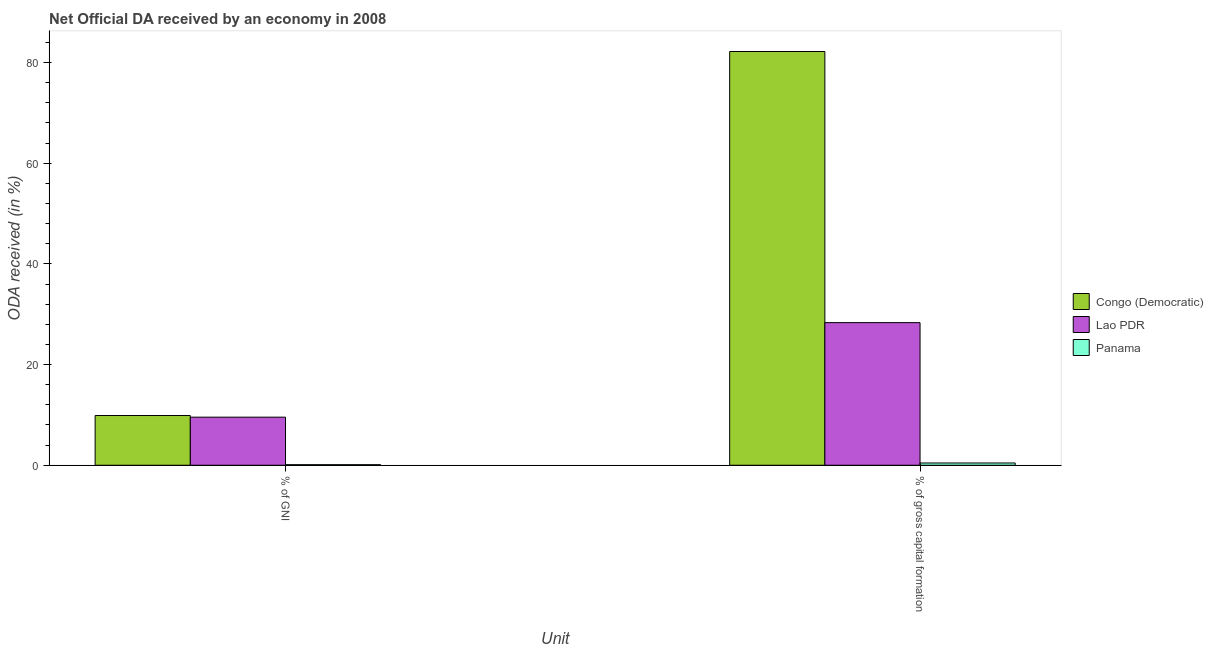How many different coloured bars are there?
Keep it short and to the point. 3. How many groups of bars are there?
Provide a short and direct response. 2. Are the number of bars on each tick of the X-axis equal?
Offer a very short reply. Yes. How many bars are there on the 2nd tick from the left?
Provide a succinct answer. 3. What is the label of the 2nd group of bars from the left?
Give a very brief answer. % of gross capital formation. What is the oda received as percentage of gni in Lao PDR?
Offer a terse response. 9.55. Across all countries, what is the maximum oda received as percentage of gni?
Your answer should be compact. 9.88. Across all countries, what is the minimum oda received as percentage of gross capital formation?
Offer a very short reply. 0.45. In which country was the oda received as percentage of gni maximum?
Offer a very short reply. Congo (Democratic). In which country was the oda received as percentage of gross capital formation minimum?
Provide a succinct answer. Panama. What is the total oda received as percentage of gross capital formation in the graph?
Your answer should be compact. 110.98. What is the difference between the oda received as percentage of gross capital formation in Congo (Democratic) and that in Panama?
Your answer should be very brief. 81.75. What is the difference between the oda received as percentage of gross capital formation in Congo (Democratic) and the oda received as percentage of gni in Panama?
Provide a short and direct response. 82.09. What is the average oda received as percentage of gross capital formation per country?
Give a very brief answer. 36.99. What is the difference between the oda received as percentage of gni and oda received as percentage of gross capital formation in Panama?
Offer a terse response. -0.34. In how many countries, is the oda received as percentage of gni greater than 68 %?
Make the answer very short. 0. What is the ratio of the oda received as percentage of gross capital formation in Lao PDR to that in Congo (Democratic)?
Offer a very short reply. 0.34. Is the oda received as percentage of gni in Congo (Democratic) less than that in Lao PDR?
Your answer should be compact. No. What does the 1st bar from the left in % of gross capital formation represents?
Your answer should be very brief. Congo (Democratic). What does the 3rd bar from the right in % of gross capital formation represents?
Provide a short and direct response. Congo (Democratic). How many countries are there in the graph?
Offer a very short reply. 3. Are the values on the major ticks of Y-axis written in scientific E-notation?
Make the answer very short. No. How are the legend labels stacked?
Provide a short and direct response. Vertical. What is the title of the graph?
Offer a terse response. Net Official DA received by an economy in 2008. Does "Tuvalu" appear as one of the legend labels in the graph?
Keep it short and to the point. No. What is the label or title of the X-axis?
Make the answer very short. Unit. What is the label or title of the Y-axis?
Offer a very short reply. ODA received (in %). What is the ODA received (in %) of Congo (Democratic) in % of GNI?
Give a very brief answer. 9.88. What is the ODA received (in %) of Lao PDR in % of GNI?
Offer a terse response. 9.55. What is the ODA received (in %) in Panama in % of GNI?
Provide a succinct answer. 0.11. What is the ODA received (in %) in Congo (Democratic) in % of gross capital formation?
Provide a succinct answer. 82.2. What is the ODA received (in %) in Lao PDR in % of gross capital formation?
Offer a very short reply. 28.33. What is the ODA received (in %) in Panama in % of gross capital formation?
Provide a succinct answer. 0.45. Across all Unit, what is the maximum ODA received (in %) of Congo (Democratic)?
Your response must be concise. 82.2. Across all Unit, what is the maximum ODA received (in %) in Lao PDR?
Give a very brief answer. 28.33. Across all Unit, what is the maximum ODA received (in %) in Panama?
Offer a terse response. 0.45. Across all Unit, what is the minimum ODA received (in %) in Congo (Democratic)?
Your answer should be compact. 9.88. Across all Unit, what is the minimum ODA received (in %) of Lao PDR?
Offer a very short reply. 9.55. Across all Unit, what is the minimum ODA received (in %) in Panama?
Ensure brevity in your answer.  0.11. What is the total ODA received (in %) of Congo (Democratic) in the graph?
Your answer should be very brief. 92.08. What is the total ODA received (in %) of Lao PDR in the graph?
Offer a very short reply. 37.88. What is the total ODA received (in %) of Panama in the graph?
Ensure brevity in your answer.  0.56. What is the difference between the ODA received (in %) in Congo (Democratic) in % of GNI and that in % of gross capital formation?
Offer a very short reply. -72.32. What is the difference between the ODA received (in %) in Lao PDR in % of GNI and that in % of gross capital formation?
Your answer should be compact. -18.78. What is the difference between the ODA received (in %) of Panama in % of GNI and that in % of gross capital formation?
Give a very brief answer. -0.34. What is the difference between the ODA received (in %) of Congo (Democratic) in % of GNI and the ODA received (in %) of Lao PDR in % of gross capital formation?
Your answer should be compact. -18.45. What is the difference between the ODA received (in %) in Congo (Democratic) in % of GNI and the ODA received (in %) in Panama in % of gross capital formation?
Ensure brevity in your answer.  9.43. What is the difference between the ODA received (in %) of Lao PDR in % of GNI and the ODA received (in %) of Panama in % of gross capital formation?
Provide a short and direct response. 9.1. What is the average ODA received (in %) in Congo (Democratic) per Unit?
Your response must be concise. 46.04. What is the average ODA received (in %) of Lao PDR per Unit?
Provide a short and direct response. 18.94. What is the average ODA received (in %) in Panama per Unit?
Provide a short and direct response. 0.28. What is the difference between the ODA received (in %) in Congo (Democratic) and ODA received (in %) in Lao PDR in % of GNI?
Offer a very short reply. 0.33. What is the difference between the ODA received (in %) of Congo (Democratic) and ODA received (in %) of Panama in % of GNI?
Provide a short and direct response. 9.77. What is the difference between the ODA received (in %) of Lao PDR and ODA received (in %) of Panama in % of GNI?
Give a very brief answer. 9.44. What is the difference between the ODA received (in %) of Congo (Democratic) and ODA received (in %) of Lao PDR in % of gross capital formation?
Ensure brevity in your answer.  53.87. What is the difference between the ODA received (in %) of Congo (Democratic) and ODA received (in %) of Panama in % of gross capital formation?
Your answer should be compact. 81.75. What is the difference between the ODA received (in %) in Lao PDR and ODA received (in %) in Panama in % of gross capital formation?
Your answer should be very brief. 27.88. What is the ratio of the ODA received (in %) of Congo (Democratic) in % of GNI to that in % of gross capital formation?
Keep it short and to the point. 0.12. What is the ratio of the ODA received (in %) in Lao PDR in % of GNI to that in % of gross capital formation?
Ensure brevity in your answer.  0.34. What is the ratio of the ODA received (in %) in Panama in % of GNI to that in % of gross capital formation?
Provide a short and direct response. 0.24. What is the difference between the highest and the second highest ODA received (in %) in Congo (Democratic)?
Your answer should be compact. 72.32. What is the difference between the highest and the second highest ODA received (in %) of Lao PDR?
Ensure brevity in your answer.  18.78. What is the difference between the highest and the second highest ODA received (in %) in Panama?
Offer a very short reply. 0.34. What is the difference between the highest and the lowest ODA received (in %) in Congo (Democratic)?
Your response must be concise. 72.32. What is the difference between the highest and the lowest ODA received (in %) in Lao PDR?
Offer a very short reply. 18.78. What is the difference between the highest and the lowest ODA received (in %) of Panama?
Offer a very short reply. 0.34. 